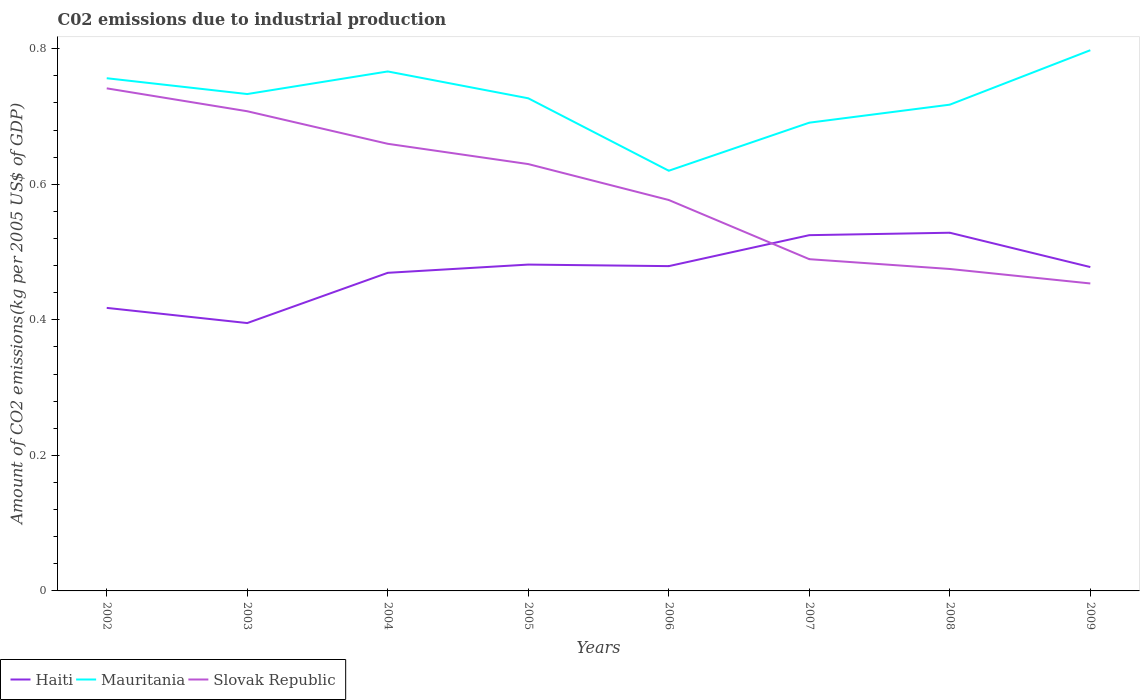Does the line corresponding to Haiti intersect with the line corresponding to Slovak Republic?
Keep it short and to the point. Yes. Across all years, what is the maximum amount of CO2 emitted due to industrial production in Slovak Republic?
Give a very brief answer. 0.45. In which year was the amount of CO2 emitted due to industrial production in Mauritania maximum?
Your answer should be compact. 2006. What is the total amount of CO2 emitted due to industrial production in Haiti in the graph?
Make the answer very short. -0.01. What is the difference between the highest and the second highest amount of CO2 emitted due to industrial production in Mauritania?
Your answer should be compact. 0.18. What is the difference between the highest and the lowest amount of CO2 emitted due to industrial production in Slovak Republic?
Your answer should be compact. 4. How many lines are there?
Give a very brief answer. 3. Does the graph contain grids?
Your answer should be very brief. No. Where does the legend appear in the graph?
Your answer should be compact. Bottom left. How many legend labels are there?
Provide a short and direct response. 3. What is the title of the graph?
Offer a terse response. C02 emissions due to industrial production. Does "Madagascar" appear as one of the legend labels in the graph?
Ensure brevity in your answer.  No. What is the label or title of the X-axis?
Provide a short and direct response. Years. What is the label or title of the Y-axis?
Make the answer very short. Amount of CO2 emissions(kg per 2005 US$ of GDP). What is the Amount of CO2 emissions(kg per 2005 US$ of GDP) in Haiti in 2002?
Provide a succinct answer. 0.42. What is the Amount of CO2 emissions(kg per 2005 US$ of GDP) of Mauritania in 2002?
Your answer should be very brief. 0.76. What is the Amount of CO2 emissions(kg per 2005 US$ of GDP) of Slovak Republic in 2002?
Provide a short and direct response. 0.74. What is the Amount of CO2 emissions(kg per 2005 US$ of GDP) in Haiti in 2003?
Ensure brevity in your answer.  0.4. What is the Amount of CO2 emissions(kg per 2005 US$ of GDP) of Mauritania in 2003?
Your response must be concise. 0.73. What is the Amount of CO2 emissions(kg per 2005 US$ of GDP) in Slovak Republic in 2003?
Offer a very short reply. 0.71. What is the Amount of CO2 emissions(kg per 2005 US$ of GDP) in Haiti in 2004?
Your response must be concise. 0.47. What is the Amount of CO2 emissions(kg per 2005 US$ of GDP) in Mauritania in 2004?
Provide a succinct answer. 0.77. What is the Amount of CO2 emissions(kg per 2005 US$ of GDP) in Slovak Republic in 2004?
Your answer should be very brief. 0.66. What is the Amount of CO2 emissions(kg per 2005 US$ of GDP) in Haiti in 2005?
Your response must be concise. 0.48. What is the Amount of CO2 emissions(kg per 2005 US$ of GDP) in Mauritania in 2005?
Give a very brief answer. 0.73. What is the Amount of CO2 emissions(kg per 2005 US$ of GDP) of Slovak Republic in 2005?
Provide a succinct answer. 0.63. What is the Amount of CO2 emissions(kg per 2005 US$ of GDP) in Haiti in 2006?
Provide a succinct answer. 0.48. What is the Amount of CO2 emissions(kg per 2005 US$ of GDP) of Mauritania in 2006?
Your response must be concise. 0.62. What is the Amount of CO2 emissions(kg per 2005 US$ of GDP) of Slovak Republic in 2006?
Offer a very short reply. 0.58. What is the Amount of CO2 emissions(kg per 2005 US$ of GDP) in Haiti in 2007?
Offer a very short reply. 0.52. What is the Amount of CO2 emissions(kg per 2005 US$ of GDP) in Mauritania in 2007?
Provide a succinct answer. 0.69. What is the Amount of CO2 emissions(kg per 2005 US$ of GDP) in Slovak Republic in 2007?
Your response must be concise. 0.49. What is the Amount of CO2 emissions(kg per 2005 US$ of GDP) of Haiti in 2008?
Give a very brief answer. 0.53. What is the Amount of CO2 emissions(kg per 2005 US$ of GDP) in Mauritania in 2008?
Give a very brief answer. 0.72. What is the Amount of CO2 emissions(kg per 2005 US$ of GDP) in Slovak Republic in 2008?
Ensure brevity in your answer.  0.48. What is the Amount of CO2 emissions(kg per 2005 US$ of GDP) in Haiti in 2009?
Provide a short and direct response. 0.48. What is the Amount of CO2 emissions(kg per 2005 US$ of GDP) of Mauritania in 2009?
Keep it short and to the point. 0.8. What is the Amount of CO2 emissions(kg per 2005 US$ of GDP) in Slovak Republic in 2009?
Your answer should be very brief. 0.45. Across all years, what is the maximum Amount of CO2 emissions(kg per 2005 US$ of GDP) of Haiti?
Your answer should be compact. 0.53. Across all years, what is the maximum Amount of CO2 emissions(kg per 2005 US$ of GDP) in Mauritania?
Your answer should be compact. 0.8. Across all years, what is the maximum Amount of CO2 emissions(kg per 2005 US$ of GDP) of Slovak Republic?
Ensure brevity in your answer.  0.74. Across all years, what is the minimum Amount of CO2 emissions(kg per 2005 US$ of GDP) in Haiti?
Offer a terse response. 0.4. Across all years, what is the minimum Amount of CO2 emissions(kg per 2005 US$ of GDP) of Mauritania?
Keep it short and to the point. 0.62. Across all years, what is the minimum Amount of CO2 emissions(kg per 2005 US$ of GDP) of Slovak Republic?
Make the answer very short. 0.45. What is the total Amount of CO2 emissions(kg per 2005 US$ of GDP) of Haiti in the graph?
Offer a terse response. 3.77. What is the total Amount of CO2 emissions(kg per 2005 US$ of GDP) in Mauritania in the graph?
Offer a terse response. 5.81. What is the total Amount of CO2 emissions(kg per 2005 US$ of GDP) of Slovak Republic in the graph?
Make the answer very short. 4.73. What is the difference between the Amount of CO2 emissions(kg per 2005 US$ of GDP) in Haiti in 2002 and that in 2003?
Provide a succinct answer. 0.02. What is the difference between the Amount of CO2 emissions(kg per 2005 US$ of GDP) of Mauritania in 2002 and that in 2003?
Your answer should be compact. 0.02. What is the difference between the Amount of CO2 emissions(kg per 2005 US$ of GDP) in Slovak Republic in 2002 and that in 2003?
Your answer should be compact. 0.03. What is the difference between the Amount of CO2 emissions(kg per 2005 US$ of GDP) of Haiti in 2002 and that in 2004?
Your response must be concise. -0.05. What is the difference between the Amount of CO2 emissions(kg per 2005 US$ of GDP) in Mauritania in 2002 and that in 2004?
Your response must be concise. -0.01. What is the difference between the Amount of CO2 emissions(kg per 2005 US$ of GDP) in Slovak Republic in 2002 and that in 2004?
Keep it short and to the point. 0.08. What is the difference between the Amount of CO2 emissions(kg per 2005 US$ of GDP) in Haiti in 2002 and that in 2005?
Your answer should be compact. -0.06. What is the difference between the Amount of CO2 emissions(kg per 2005 US$ of GDP) of Mauritania in 2002 and that in 2005?
Your response must be concise. 0.03. What is the difference between the Amount of CO2 emissions(kg per 2005 US$ of GDP) of Slovak Republic in 2002 and that in 2005?
Keep it short and to the point. 0.11. What is the difference between the Amount of CO2 emissions(kg per 2005 US$ of GDP) in Haiti in 2002 and that in 2006?
Offer a very short reply. -0.06. What is the difference between the Amount of CO2 emissions(kg per 2005 US$ of GDP) in Mauritania in 2002 and that in 2006?
Provide a short and direct response. 0.14. What is the difference between the Amount of CO2 emissions(kg per 2005 US$ of GDP) of Slovak Republic in 2002 and that in 2006?
Offer a terse response. 0.16. What is the difference between the Amount of CO2 emissions(kg per 2005 US$ of GDP) in Haiti in 2002 and that in 2007?
Your answer should be very brief. -0.11. What is the difference between the Amount of CO2 emissions(kg per 2005 US$ of GDP) in Mauritania in 2002 and that in 2007?
Your response must be concise. 0.07. What is the difference between the Amount of CO2 emissions(kg per 2005 US$ of GDP) of Slovak Republic in 2002 and that in 2007?
Provide a short and direct response. 0.25. What is the difference between the Amount of CO2 emissions(kg per 2005 US$ of GDP) in Haiti in 2002 and that in 2008?
Ensure brevity in your answer.  -0.11. What is the difference between the Amount of CO2 emissions(kg per 2005 US$ of GDP) of Mauritania in 2002 and that in 2008?
Offer a very short reply. 0.04. What is the difference between the Amount of CO2 emissions(kg per 2005 US$ of GDP) in Slovak Republic in 2002 and that in 2008?
Give a very brief answer. 0.27. What is the difference between the Amount of CO2 emissions(kg per 2005 US$ of GDP) in Haiti in 2002 and that in 2009?
Your answer should be compact. -0.06. What is the difference between the Amount of CO2 emissions(kg per 2005 US$ of GDP) in Mauritania in 2002 and that in 2009?
Make the answer very short. -0.04. What is the difference between the Amount of CO2 emissions(kg per 2005 US$ of GDP) in Slovak Republic in 2002 and that in 2009?
Your response must be concise. 0.29. What is the difference between the Amount of CO2 emissions(kg per 2005 US$ of GDP) of Haiti in 2003 and that in 2004?
Offer a terse response. -0.07. What is the difference between the Amount of CO2 emissions(kg per 2005 US$ of GDP) in Mauritania in 2003 and that in 2004?
Offer a very short reply. -0.03. What is the difference between the Amount of CO2 emissions(kg per 2005 US$ of GDP) in Slovak Republic in 2003 and that in 2004?
Your answer should be very brief. 0.05. What is the difference between the Amount of CO2 emissions(kg per 2005 US$ of GDP) in Haiti in 2003 and that in 2005?
Give a very brief answer. -0.09. What is the difference between the Amount of CO2 emissions(kg per 2005 US$ of GDP) of Mauritania in 2003 and that in 2005?
Ensure brevity in your answer.  0.01. What is the difference between the Amount of CO2 emissions(kg per 2005 US$ of GDP) in Slovak Republic in 2003 and that in 2005?
Provide a short and direct response. 0.08. What is the difference between the Amount of CO2 emissions(kg per 2005 US$ of GDP) in Haiti in 2003 and that in 2006?
Keep it short and to the point. -0.08. What is the difference between the Amount of CO2 emissions(kg per 2005 US$ of GDP) of Mauritania in 2003 and that in 2006?
Offer a very short reply. 0.11. What is the difference between the Amount of CO2 emissions(kg per 2005 US$ of GDP) in Slovak Republic in 2003 and that in 2006?
Your response must be concise. 0.13. What is the difference between the Amount of CO2 emissions(kg per 2005 US$ of GDP) of Haiti in 2003 and that in 2007?
Provide a short and direct response. -0.13. What is the difference between the Amount of CO2 emissions(kg per 2005 US$ of GDP) of Mauritania in 2003 and that in 2007?
Keep it short and to the point. 0.04. What is the difference between the Amount of CO2 emissions(kg per 2005 US$ of GDP) in Slovak Republic in 2003 and that in 2007?
Your answer should be very brief. 0.22. What is the difference between the Amount of CO2 emissions(kg per 2005 US$ of GDP) of Haiti in 2003 and that in 2008?
Your answer should be very brief. -0.13. What is the difference between the Amount of CO2 emissions(kg per 2005 US$ of GDP) of Mauritania in 2003 and that in 2008?
Give a very brief answer. 0.02. What is the difference between the Amount of CO2 emissions(kg per 2005 US$ of GDP) of Slovak Republic in 2003 and that in 2008?
Offer a very short reply. 0.23. What is the difference between the Amount of CO2 emissions(kg per 2005 US$ of GDP) in Haiti in 2003 and that in 2009?
Make the answer very short. -0.08. What is the difference between the Amount of CO2 emissions(kg per 2005 US$ of GDP) of Mauritania in 2003 and that in 2009?
Give a very brief answer. -0.06. What is the difference between the Amount of CO2 emissions(kg per 2005 US$ of GDP) of Slovak Republic in 2003 and that in 2009?
Provide a succinct answer. 0.25. What is the difference between the Amount of CO2 emissions(kg per 2005 US$ of GDP) in Haiti in 2004 and that in 2005?
Provide a short and direct response. -0.01. What is the difference between the Amount of CO2 emissions(kg per 2005 US$ of GDP) in Mauritania in 2004 and that in 2005?
Offer a terse response. 0.04. What is the difference between the Amount of CO2 emissions(kg per 2005 US$ of GDP) in Slovak Republic in 2004 and that in 2005?
Offer a terse response. 0.03. What is the difference between the Amount of CO2 emissions(kg per 2005 US$ of GDP) in Haiti in 2004 and that in 2006?
Provide a short and direct response. -0.01. What is the difference between the Amount of CO2 emissions(kg per 2005 US$ of GDP) in Mauritania in 2004 and that in 2006?
Ensure brevity in your answer.  0.15. What is the difference between the Amount of CO2 emissions(kg per 2005 US$ of GDP) in Slovak Republic in 2004 and that in 2006?
Offer a terse response. 0.08. What is the difference between the Amount of CO2 emissions(kg per 2005 US$ of GDP) of Haiti in 2004 and that in 2007?
Your response must be concise. -0.06. What is the difference between the Amount of CO2 emissions(kg per 2005 US$ of GDP) in Mauritania in 2004 and that in 2007?
Ensure brevity in your answer.  0.08. What is the difference between the Amount of CO2 emissions(kg per 2005 US$ of GDP) of Slovak Republic in 2004 and that in 2007?
Keep it short and to the point. 0.17. What is the difference between the Amount of CO2 emissions(kg per 2005 US$ of GDP) in Haiti in 2004 and that in 2008?
Ensure brevity in your answer.  -0.06. What is the difference between the Amount of CO2 emissions(kg per 2005 US$ of GDP) of Mauritania in 2004 and that in 2008?
Keep it short and to the point. 0.05. What is the difference between the Amount of CO2 emissions(kg per 2005 US$ of GDP) of Slovak Republic in 2004 and that in 2008?
Provide a succinct answer. 0.18. What is the difference between the Amount of CO2 emissions(kg per 2005 US$ of GDP) in Haiti in 2004 and that in 2009?
Keep it short and to the point. -0.01. What is the difference between the Amount of CO2 emissions(kg per 2005 US$ of GDP) in Mauritania in 2004 and that in 2009?
Provide a succinct answer. -0.03. What is the difference between the Amount of CO2 emissions(kg per 2005 US$ of GDP) in Slovak Republic in 2004 and that in 2009?
Provide a succinct answer. 0.21. What is the difference between the Amount of CO2 emissions(kg per 2005 US$ of GDP) of Haiti in 2005 and that in 2006?
Your response must be concise. 0. What is the difference between the Amount of CO2 emissions(kg per 2005 US$ of GDP) in Mauritania in 2005 and that in 2006?
Your answer should be very brief. 0.11. What is the difference between the Amount of CO2 emissions(kg per 2005 US$ of GDP) of Slovak Republic in 2005 and that in 2006?
Give a very brief answer. 0.05. What is the difference between the Amount of CO2 emissions(kg per 2005 US$ of GDP) of Haiti in 2005 and that in 2007?
Give a very brief answer. -0.04. What is the difference between the Amount of CO2 emissions(kg per 2005 US$ of GDP) of Mauritania in 2005 and that in 2007?
Give a very brief answer. 0.04. What is the difference between the Amount of CO2 emissions(kg per 2005 US$ of GDP) of Slovak Republic in 2005 and that in 2007?
Ensure brevity in your answer.  0.14. What is the difference between the Amount of CO2 emissions(kg per 2005 US$ of GDP) of Haiti in 2005 and that in 2008?
Your answer should be very brief. -0.05. What is the difference between the Amount of CO2 emissions(kg per 2005 US$ of GDP) in Mauritania in 2005 and that in 2008?
Provide a short and direct response. 0.01. What is the difference between the Amount of CO2 emissions(kg per 2005 US$ of GDP) of Slovak Republic in 2005 and that in 2008?
Make the answer very short. 0.15. What is the difference between the Amount of CO2 emissions(kg per 2005 US$ of GDP) of Haiti in 2005 and that in 2009?
Provide a short and direct response. 0. What is the difference between the Amount of CO2 emissions(kg per 2005 US$ of GDP) in Mauritania in 2005 and that in 2009?
Provide a succinct answer. -0.07. What is the difference between the Amount of CO2 emissions(kg per 2005 US$ of GDP) in Slovak Republic in 2005 and that in 2009?
Make the answer very short. 0.18. What is the difference between the Amount of CO2 emissions(kg per 2005 US$ of GDP) in Haiti in 2006 and that in 2007?
Keep it short and to the point. -0.05. What is the difference between the Amount of CO2 emissions(kg per 2005 US$ of GDP) of Mauritania in 2006 and that in 2007?
Offer a very short reply. -0.07. What is the difference between the Amount of CO2 emissions(kg per 2005 US$ of GDP) in Slovak Republic in 2006 and that in 2007?
Offer a very short reply. 0.09. What is the difference between the Amount of CO2 emissions(kg per 2005 US$ of GDP) of Haiti in 2006 and that in 2008?
Ensure brevity in your answer.  -0.05. What is the difference between the Amount of CO2 emissions(kg per 2005 US$ of GDP) in Mauritania in 2006 and that in 2008?
Offer a terse response. -0.1. What is the difference between the Amount of CO2 emissions(kg per 2005 US$ of GDP) in Slovak Republic in 2006 and that in 2008?
Your answer should be very brief. 0.1. What is the difference between the Amount of CO2 emissions(kg per 2005 US$ of GDP) of Haiti in 2006 and that in 2009?
Give a very brief answer. 0. What is the difference between the Amount of CO2 emissions(kg per 2005 US$ of GDP) of Mauritania in 2006 and that in 2009?
Provide a short and direct response. -0.18. What is the difference between the Amount of CO2 emissions(kg per 2005 US$ of GDP) of Slovak Republic in 2006 and that in 2009?
Provide a succinct answer. 0.12. What is the difference between the Amount of CO2 emissions(kg per 2005 US$ of GDP) of Haiti in 2007 and that in 2008?
Your answer should be very brief. -0. What is the difference between the Amount of CO2 emissions(kg per 2005 US$ of GDP) in Mauritania in 2007 and that in 2008?
Your answer should be very brief. -0.03. What is the difference between the Amount of CO2 emissions(kg per 2005 US$ of GDP) in Slovak Republic in 2007 and that in 2008?
Your response must be concise. 0.01. What is the difference between the Amount of CO2 emissions(kg per 2005 US$ of GDP) of Haiti in 2007 and that in 2009?
Give a very brief answer. 0.05. What is the difference between the Amount of CO2 emissions(kg per 2005 US$ of GDP) of Mauritania in 2007 and that in 2009?
Provide a succinct answer. -0.11. What is the difference between the Amount of CO2 emissions(kg per 2005 US$ of GDP) of Slovak Republic in 2007 and that in 2009?
Give a very brief answer. 0.04. What is the difference between the Amount of CO2 emissions(kg per 2005 US$ of GDP) in Haiti in 2008 and that in 2009?
Your answer should be compact. 0.05. What is the difference between the Amount of CO2 emissions(kg per 2005 US$ of GDP) of Mauritania in 2008 and that in 2009?
Your answer should be very brief. -0.08. What is the difference between the Amount of CO2 emissions(kg per 2005 US$ of GDP) in Slovak Republic in 2008 and that in 2009?
Your answer should be very brief. 0.02. What is the difference between the Amount of CO2 emissions(kg per 2005 US$ of GDP) of Haiti in 2002 and the Amount of CO2 emissions(kg per 2005 US$ of GDP) of Mauritania in 2003?
Provide a short and direct response. -0.32. What is the difference between the Amount of CO2 emissions(kg per 2005 US$ of GDP) in Haiti in 2002 and the Amount of CO2 emissions(kg per 2005 US$ of GDP) in Slovak Republic in 2003?
Your answer should be compact. -0.29. What is the difference between the Amount of CO2 emissions(kg per 2005 US$ of GDP) in Mauritania in 2002 and the Amount of CO2 emissions(kg per 2005 US$ of GDP) in Slovak Republic in 2003?
Your answer should be compact. 0.05. What is the difference between the Amount of CO2 emissions(kg per 2005 US$ of GDP) in Haiti in 2002 and the Amount of CO2 emissions(kg per 2005 US$ of GDP) in Mauritania in 2004?
Make the answer very short. -0.35. What is the difference between the Amount of CO2 emissions(kg per 2005 US$ of GDP) in Haiti in 2002 and the Amount of CO2 emissions(kg per 2005 US$ of GDP) in Slovak Republic in 2004?
Ensure brevity in your answer.  -0.24. What is the difference between the Amount of CO2 emissions(kg per 2005 US$ of GDP) of Mauritania in 2002 and the Amount of CO2 emissions(kg per 2005 US$ of GDP) of Slovak Republic in 2004?
Make the answer very short. 0.1. What is the difference between the Amount of CO2 emissions(kg per 2005 US$ of GDP) in Haiti in 2002 and the Amount of CO2 emissions(kg per 2005 US$ of GDP) in Mauritania in 2005?
Keep it short and to the point. -0.31. What is the difference between the Amount of CO2 emissions(kg per 2005 US$ of GDP) of Haiti in 2002 and the Amount of CO2 emissions(kg per 2005 US$ of GDP) of Slovak Republic in 2005?
Your response must be concise. -0.21. What is the difference between the Amount of CO2 emissions(kg per 2005 US$ of GDP) of Mauritania in 2002 and the Amount of CO2 emissions(kg per 2005 US$ of GDP) of Slovak Republic in 2005?
Your response must be concise. 0.13. What is the difference between the Amount of CO2 emissions(kg per 2005 US$ of GDP) of Haiti in 2002 and the Amount of CO2 emissions(kg per 2005 US$ of GDP) of Mauritania in 2006?
Make the answer very short. -0.2. What is the difference between the Amount of CO2 emissions(kg per 2005 US$ of GDP) of Haiti in 2002 and the Amount of CO2 emissions(kg per 2005 US$ of GDP) of Slovak Republic in 2006?
Ensure brevity in your answer.  -0.16. What is the difference between the Amount of CO2 emissions(kg per 2005 US$ of GDP) of Mauritania in 2002 and the Amount of CO2 emissions(kg per 2005 US$ of GDP) of Slovak Republic in 2006?
Your response must be concise. 0.18. What is the difference between the Amount of CO2 emissions(kg per 2005 US$ of GDP) of Haiti in 2002 and the Amount of CO2 emissions(kg per 2005 US$ of GDP) of Mauritania in 2007?
Ensure brevity in your answer.  -0.27. What is the difference between the Amount of CO2 emissions(kg per 2005 US$ of GDP) of Haiti in 2002 and the Amount of CO2 emissions(kg per 2005 US$ of GDP) of Slovak Republic in 2007?
Make the answer very short. -0.07. What is the difference between the Amount of CO2 emissions(kg per 2005 US$ of GDP) of Mauritania in 2002 and the Amount of CO2 emissions(kg per 2005 US$ of GDP) of Slovak Republic in 2007?
Provide a short and direct response. 0.27. What is the difference between the Amount of CO2 emissions(kg per 2005 US$ of GDP) in Haiti in 2002 and the Amount of CO2 emissions(kg per 2005 US$ of GDP) in Mauritania in 2008?
Your answer should be very brief. -0.3. What is the difference between the Amount of CO2 emissions(kg per 2005 US$ of GDP) of Haiti in 2002 and the Amount of CO2 emissions(kg per 2005 US$ of GDP) of Slovak Republic in 2008?
Your response must be concise. -0.06. What is the difference between the Amount of CO2 emissions(kg per 2005 US$ of GDP) of Mauritania in 2002 and the Amount of CO2 emissions(kg per 2005 US$ of GDP) of Slovak Republic in 2008?
Offer a very short reply. 0.28. What is the difference between the Amount of CO2 emissions(kg per 2005 US$ of GDP) of Haiti in 2002 and the Amount of CO2 emissions(kg per 2005 US$ of GDP) of Mauritania in 2009?
Give a very brief answer. -0.38. What is the difference between the Amount of CO2 emissions(kg per 2005 US$ of GDP) of Haiti in 2002 and the Amount of CO2 emissions(kg per 2005 US$ of GDP) of Slovak Republic in 2009?
Provide a succinct answer. -0.04. What is the difference between the Amount of CO2 emissions(kg per 2005 US$ of GDP) in Mauritania in 2002 and the Amount of CO2 emissions(kg per 2005 US$ of GDP) in Slovak Republic in 2009?
Offer a terse response. 0.3. What is the difference between the Amount of CO2 emissions(kg per 2005 US$ of GDP) of Haiti in 2003 and the Amount of CO2 emissions(kg per 2005 US$ of GDP) of Mauritania in 2004?
Your answer should be compact. -0.37. What is the difference between the Amount of CO2 emissions(kg per 2005 US$ of GDP) of Haiti in 2003 and the Amount of CO2 emissions(kg per 2005 US$ of GDP) of Slovak Republic in 2004?
Provide a short and direct response. -0.26. What is the difference between the Amount of CO2 emissions(kg per 2005 US$ of GDP) of Mauritania in 2003 and the Amount of CO2 emissions(kg per 2005 US$ of GDP) of Slovak Republic in 2004?
Offer a very short reply. 0.07. What is the difference between the Amount of CO2 emissions(kg per 2005 US$ of GDP) in Haiti in 2003 and the Amount of CO2 emissions(kg per 2005 US$ of GDP) in Mauritania in 2005?
Your answer should be compact. -0.33. What is the difference between the Amount of CO2 emissions(kg per 2005 US$ of GDP) of Haiti in 2003 and the Amount of CO2 emissions(kg per 2005 US$ of GDP) of Slovak Republic in 2005?
Your answer should be very brief. -0.23. What is the difference between the Amount of CO2 emissions(kg per 2005 US$ of GDP) in Mauritania in 2003 and the Amount of CO2 emissions(kg per 2005 US$ of GDP) in Slovak Republic in 2005?
Provide a succinct answer. 0.1. What is the difference between the Amount of CO2 emissions(kg per 2005 US$ of GDP) in Haiti in 2003 and the Amount of CO2 emissions(kg per 2005 US$ of GDP) in Mauritania in 2006?
Make the answer very short. -0.22. What is the difference between the Amount of CO2 emissions(kg per 2005 US$ of GDP) of Haiti in 2003 and the Amount of CO2 emissions(kg per 2005 US$ of GDP) of Slovak Republic in 2006?
Keep it short and to the point. -0.18. What is the difference between the Amount of CO2 emissions(kg per 2005 US$ of GDP) of Mauritania in 2003 and the Amount of CO2 emissions(kg per 2005 US$ of GDP) of Slovak Republic in 2006?
Provide a short and direct response. 0.16. What is the difference between the Amount of CO2 emissions(kg per 2005 US$ of GDP) of Haiti in 2003 and the Amount of CO2 emissions(kg per 2005 US$ of GDP) of Mauritania in 2007?
Ensure brevity in your answer.  -0.3. What is the difference between the Amount of CO2 emissions(kg per 2005 US$ of GDP) of Haiti in 2003 and the Amount of CO2 emissions(kg per 2005 US$ of GDP) of Slovak Republic in 2007?
Keep it short and to the point. -0.09. What is the difference between the Amount of CO2 emissions(kg per 2005 US$ of GDP) of Mauritania in 2003 and the Amount of CO2 emissions(kg per 2005 US$ of GDP) of Slovak Republic in 2007?
Provide a short and direct response. 0.24. What is the difference between the Amount of CO2 emissions(kg per 2005 US$ of GDP) of Haiti in 2003 and the Amount of CO2 emissions(kg per 2005 US$ of GDP) of Mauritania in 2008?
Give a very brief answer. -0.32. What is the difference between the Amount of CO2 emissions(kg per 2005 US$ of GDP) of Haiti in 2003 and the Amount of CO2 emissions(kg per 2005 US$ of GDP) of Slovak Republic in 2008?
Offer a very short reply. -0.08. What is the difference between the Amount of CO2 emissions(kg per 2005 US$ of GDP) of Mauritania in 2003 and the Amount of CO2 emissions(kg per 2005 US$ of GDP) of Slovak Republic in 2008?
Give a very brief answer. 0.26. What is the difference between the Amount of CO2 emissions(kg per 2005 US$ of GDP) of Haiti in 2003 and the Amount of CO2 emissions(kg per 2005 US$ of GDP) of Mauritania in 2009?
Your answer should be compact. -0.4. What is the difference between the Amount of CO2 emissions(kg per 2005 US$ of GDP) in Haiti in 2003 and the Amount of CO2 emissions(kg per 2005 US$ of GDP) in Slovak Republic in 2009?
Offer a very short reply. -0.06. What is the difference between the Amount of CO2 emissions(kg per 2005 US$ of GDP) of Mauritania in 2003 and the Amount of CO2 emissions(kg per 2005 US$ of GDP) of Slovak Republic in 2009?
Give a very brief answer. 0.28. What is the difference between the Amount of CO2 emissions(kg per 2005 US$ of GDP) of Haiti in 2004 and the Amount of CO2 emissions(kg per 2005 US$ of GDP) of Mauritania in 2005?
Provide a short and direct response. -0.26. What is the difference between the Amount of CO2 emissions(kg per 2005 US$ of GDP) of Haiti in 2004 and the Amount of CO2 emissions(kg per 2005 US$ of GDP) of Slovak Republic in 2005?
Keep it short and to the point. -0.16. What is the difference between the Amount of CO2 emissions(kg per 2005 US$ of GDP) in Mauritania in 2004 and the Amount of CO2 emissions(kg per 2005 US$ of GDP) in Slovak Republic in 2005?
Your response must be concise. 0.14. What is the difference between the Amount of CO2 emissions(kg per 2005 US$ of GDP) in Haiti in 2004 and the Amount of CO2 emissions(kg per 2005 US$ of GDP) in Mauritania in 2006?
Ensure brevity in your answer.  -0.15. What is the difference between the Amount of CO2 emissions(kg per 2005 US$ of GDP) in Haiti in 2004 and the Amount of CO2 emissions(kg per 2005 US$ of GDP) in Slovak Republic in 2006?
Your answer should be compact. -0.11. What is the difference between the Amount of CO2 emissions(kg per 2005 US$ of GDP) of Mauritania in 2004 and the Amount of CO2 emissions(kg per 2005 US$ of GDP) of Slovak Republic in 2006?
Provide a succinct answer. 0.19. What is the difference between the Amount of CO2 emissions(kg per 2005 US$ of GDP) of Haiti in 2004 and the Amount of CO2 emissions(kg per 2005 US$ of GDP) of Mauritania in 2007?
Keep it short and to the point. -0.22. What is the difference between the Amount of CO2 emissions(kg per 2005 US$ of GDP) of Haiti in 2004 and the Amount of CO2 emissions(kg per 2005 US$ of GDP) of Slovak Republic in 2007?
Offer a terse response. -0.02. What is the difference between the Amount of CO2 emissions(kg per 2005 US$ of GDP) of Mauritania in 2004 and the Amount of CO2 emissions(kg per 2005 US$ of GDP) of Slovak Republic in 2007?
Make the answer very short. 0.28. What is the difference between the Amount of CO2 emissions(kg per 2005 US$ of GDP) in Haiti in 2004 and the Amount of CO2 emissions(kg per 2005 US$ of GDP) in Mauritania in 2008?
Keep it short and to the point. -0.25. What is the difference between the Amount of CO2 emissions(kg per 2005 US$ of GDP) of Haiti in 2004 and the Amount of CO2 emissions(kg per 2005 US$ of GDP) of Slovak Republic in 2008?
Ensure brevity in your answer.  -0.01. What is the difference between the Amount of CO2 emissions(kg per 2005 US$ of GDP) of Mauritania in 2004 and the Amount of CO2 emissions(kg per 2005 US$ of GDP) of Slovak Republic in 2008?
Offer a very short reply. 0.29. What is the difference between the Amount of CO2 emissions(kg per 2005 US$ of GDP) in Haiti in 2004 and the Amount of CO2 emissions(kg per 2005 US$ of GDP) in Mauritania in 2009?
Your response must be concise. -0.33. What is the difference between the Amount of CO2 emissions(kg per 2005 US$ of GDP) in Haiti in 2004 and the Amount of CO2 emissions(kg per 2005 US$ of GDP) in Slovak Republic in 2009?
Keep it short and to the point. 0.02. What is the difference between the Amount of CO2 emissions(kg per 2005 US$ of GDP) in Mauritania in 2004 and the Amount of CO2 emissions(kg per 2005 US$ of GDP) in Slovak Republic in 2009?
Keep it short and to the point. 0.31. What is the difference between the Amount of CO2 emissions(kg per 2005 US$ of GDP) of Haiti in 2005 and the Amount of CO2 emissions(kg per 2005 US$ of GDP) of Mauritania in 2006?
Offer a very short reply. -0.14. What is the difference between the Amount of CO2 emissions(kg per 2005 US$ of GDP) in Haiti in 2005 and the Amount of CO2 emissions(kg per 2005 US$ of GDP) in Slovak Republic in 2006?
Your response must be concise. -0.1. What is the difference between the Amount of CO2 emissions(kg per 2005 US$ of GDP) of Mauritania in 2005 and the Amount of CO2 emissions(kg per 2005 US$ of GDP) of Slovak Republic in 2006?
Your response must be concise. 0.15. What is the difference between the Amount of CO2 emissions(kg per 2005 US$ of GDP) of Haiti in 2005 and the Amount of CO2 emissions(kg per 2005 US$ of GDP) of Mauritania in 2007?
Make the answer very short. -0.21. What is the difference between the Amount of CO2 emissions(kg per 2005 US$ of GDP) in Haiti in 2005 and the Amount of CO2 emissions(kg per 2005 US$ of GDP) in Slovak Republic in 2007?
Provide a succinct answer. -0.01. What is the difference between the Amount of CO2 emissions(kg per 2005 US$ of GDP) in Mauritania in 2005 and the Amount of CO2 emissions(kg per 2005 US$ of GDP) in Slovak Republic in 2007?
Your answer should be compact. 0.24. What is the difference between the Amount of CO2 emissions(kg per 2005 US$ of GDP) in Haiti in 2005 and the Amount of CO2 emissions(kg per 2005 US$ of GDP) in Mauritania in 2008?
Your answer should be very brief. -0.24. What is the difference between the Amount of CO2 emissions(kg per 2005 US$ of GDP) of Haiti in 2005 and the Amount of CO2 emissions(kg per 2005 US$ of GDP) of Slovak Republic in 2008?
Offer a terse response. 0.01. What is the difference between the Amount of CO2 emissions(kg per 2005 US$ of GDP) of Mauritania in 2005 and the Amount of CO2 emissions(kg per 2005 US$ of GDP) of Slovak Republic in 2008?
Offer a terse response. 0.25. What is the difference between the Amount of CO2 emissions(kg per 2005 US$ of GDP) in Haiti in 2005 and the Amount of CO2 emissions(kg per 2005 US$ of GDP) in Mauritania in 2009?
Your answer should be very brief. -0.32. What is the difference between the Amount of CO2 emissions(kg per 2005 US$ of GDP) in Haiti in 2005 and the Amount of CO2 emissions(kg per 2005 US$ of GDP) in Slovak Republic in 2009?
Make the answer very short. 0.03. What is the difference between the Amount of CO2 emissions(kg per 2005 US$ of GDP) in Mauritania in 2005 and the Amount of CO2 emissions(kg per 2005 US$ of GDP) in Slovak Republic in 2009?
Your response must be concise. 0.27. What is the difference between the Amount of CO2 emissions(kg per 2005 US$ of GDP) in Haiti in 2006 and the Amount of CO2 emissions(kg per 2005 US$ of GDP) in Mauritania in 2007?
Provide a short and direct response. -0.21. What is the difference between the Amount of CO2 emissions(kg per 2005 US$ of GDP) in Haiti in 2006 and the Amount of CO2 emissions(kg per 2005 US$ of GDP) in Slovak Republic in 2007?
Provide a succinct answer. -0.01. What is the difference between the Amount of CO2 emissions(kg per 2005 US$ of GDP) in Mauritania in 2006 and the Amount of CO2 emissions(kg per 2005 US$ of GDP) in Slovak Republic in 2007?
Offer a terse response. 0.13. What is the difference between the Amount of CO2 emissions(kg per 2005 US$ of GDP) in Haiti in 2006 and the Amount of CO2 emissions(kg per 2005 US$ of GDP) in Mauritania in 2008?
Keep it short and to the point. -0.24. What is the difference between the Amount of CO2 emissions(kg per 2005 US$ of GDP) in Haiti in 2006 and the Amount of CO2 emissions(kg per 2005 US$ of GDP) in Slovak Republic in 2008?
Offer a very short reply. 0. What is the difference between the Amount of CO2 emissions(kg per 2005 US$ of GDP) in Mauritania in 2006 and the Amount of CO2 emissions(kg per 2005 US$ of GDP) in Slovak Republic in 2008?
Ensure brevity in your answer.  0.14. What is the difference between the Amount of CO2 emissions(kg per 2005 US$ of GDP) of Haiti in 2006 and the Amount of CO2 emissions(kg per 2005 US$ of GDP) of Mauritania in 2009?
Offer a very short reply. -0.32. What is the difference between the Amount of CO2 emissions(kg per 2005 US$ of GDP) of Haiti in 2006 and the Amount of CO2 emissions(kg per 2005 US$ of GDP) of Slovak Republic in 2009?
Keep it short and to the point. 0.03. What is the difference between the Amount of CO2 emissions(kg per 2005 US$ of GDP) of Mauritania in 2006 and the Amount of CO2 emissions(kg per 2005 US$ of GDP) of Slovak Republic in 2009?
Your answer should be very brief. 0.17. What is the difference between the Amount of CO2 emissions(kg per 2005 US$ of GDP) in Haiti in 2007 and the Amount of CO2 emissions(kg per 2005 US$ of GDP) in Mauritania in 2008?
Your answer should be compact. -0.19. What is the difference between the Amount of CO2 emissions(kg per 2005 US$ of GDP) of Haiti in 2007 and the Amount of CO2 emissions(kg per 2005 US$ of GDP) of Slovak Republic in 2008?
Your answer should be very brief. 0.05. What is the difference between the Amount of CO2 emissions(kg per 2005 US$ of GDP) in Mauritania in 2007 and the Amount of CO2 emissions(kg per 2005 US$ of GDP) in Slovak Republic in 2008?
Offer a terse response. 0.22. What is the difference between the Amount of CO2 emissions(kg per 2005 US$ of GDP) in Haiti in 2007 and the Amount of CO2 emissions(kg per 2005 US$ of GDP) in Mauritania in 2009?
Ensure brevity in your answer.  -0.27. What is the difference between the Amount of CO2 emissions(kg per 2005 US$ of GDP) in Haiti in 2007 and the Amount of CO2 emissions(kg per 2005 US$ of GDP) in Slovak Republic in 2009?
Ensure brevity in your answer.  0.07. What is the difference between the Amount of CO2 emissions(kg per 2005 US$ of GDP) of Mauritania in 2007 and the Amount of CO2 emissions(kg per 2005 US$ of GDP) of Slovak Republic in 2009?
Provide a short and direct response. 0.24. What is the difference between the Amount of CO2 emissions(kg per 2005 US$ of GDP) of Haiti in 2008 and the Amount of CO2 emissions(kg per 2005 US$ of GDP) of Mauritania in 2009?
Offer a very short reply. -0.27. What is the difference between the Amount of CO2 emissions(kg per 2005 US$ of GDP) in Haiti in 2008 and the Amount of CO2 emissions(kg per 2005 US$ of GDP) in Slovak Republic in 2009?
Ensure brevity in your answer.  0.07. What is the difference between the Amount of CO2 emissions(kg per 2005 US$ of GDP) in Mauritania in 2008 and the Amount of CO2 emissions(kg per 2005 US$ of GDP) in Slovak Republic in 2009?
Make the answer very short. 0.26. What is the average Amount of CO2 emissions(kg per 2005 US$ of GDP) in Haiti per year?
Provide a short and direct response. 0.47. What is the average Amount of CO2 emissions(kg per 2005 US$ of GDP) of Mauritania per year?
Offer a very short reply. 0.73. What is the average Amount of CO2 emissions(kg per 2005 US$ of GDP) of Slovak Republic per year?
Ensure brevity in your answer.  0.59. In the year 2002, what is the difference between the Amount of CO2 emissions(kg per 2005 US$ of GDP) of Haiti and Amount of CO2 emissions(kg per 2005 US$ of GDP) of Mauritania?
Ensure brevity in your answer.  -0.34. In the year 2002, what is the difference between the Amount of CO2 emissions(kg per 2005 US$ of GDP) in Haiti and Amount of CO2 emissions(kg per 2005 US$ of GDP) in Slovak Republic?
Offer a very short reply. -0.32. In the year 2002, what is the difference between the Amount of CO2 emissions(kg per 2005 US$ of GDP) in Mauritania and Amount of CO2 emissions(kg per 2005 US$ of GDP) in Slovak Republic?
Give a very brief answer. 0.01. In the year 2003, what is the difference between the Amount of CO2 emissions(kg per 2005 US$ of GDP) in Haiti and Amount of CO2 emissions(kg per 2005 US$ of GDP) in Mauritania?
Provide a short and direct response. -0.34. In the year 2003, what is the difference between the Amount of CO2 emissions(kg per 2005 US$ of GDP) of Haiti and Amount of CO2 emissions(kg per 2005 US$ of GDP) of Slovak Republic?
Your answer should be compact. -0.31. In the year 2003, what is the difference between the Amount of CO2 emissions(kg per 2005 US$ of GDP) of Mauritania and Amount of CO2 emissions(kg per 2005 US$ of GDP) of Slovak Republic?
Your response must be concise. 0.03. In the year 2004, what is the difference between the Amount of CO2 emissions(kg per 2005 US$ of GDP) in Haiti and Amount of CO2 emissions(kg per 2005 US$ of GDP) in Mauritania?
Your answer should be compact. -0.3. In the year 2004, what is the difference between the Amount of CO2 emissions(kg per 2005 US$ of GDP) in Haiti and Amount of CO2 emissions(kg per 2005 US$ of GDP) in Slovak Republic?
Your response must be concise. -0.19. In the year 2004, what is the difference between the Amount of CO2 emissions(kg per 2005 US$ of GDP) of Mauritania and Amount of CO2 emissions(kg per 2005 US$ of GDP) of Slovak Republic?
Offer a terse response. 0.11. In the year 2005, what is the difference between the Amount of CO2 emissions(kg per 2005 US$ of GDP) of Haiti and Amount of CO2 emissions(kg per 2005 US$ of GDP) of Mauritania?
Keep it short and to the point. -0.25. In the year 2005, what is the difference between the Amount of CO2 emissions(kg per 2005 US$ of GDP) in Haiti and Amount of CO2 emissions(kg per 2005 US$ of GDP) in Slovak Republic?
Keep it short and to the point. -0.15. In the year 2005, what is the difference between the Amount of CO2 emissions(kg per 2005 US$ of GDP) of Mauritania and Amount of CO2 emissions(kg per 2005 US$ of GDP) of Slovak Republic?
Offer a very short reply. 0.1. In the year 2006, what is the difference between the Amount of CO2 emissions(kg per 2005 US$ of GDP) of Haiti and Amount of CO2 emissions(kg per 2005 US$ of GDP) of Mauritania?
Offer a very short reply. -0.14. In the year 2006, what is the difference between the Amount of CO2 emissions(kg per 2005 US$ of GDP) of Haiti and Amount of CO2 emissions(kg per 2005 US$ of GDP) of Slovak Republic?
Provide a short and direct response. -0.1. In the year 2006, what is the difference between the Amount of CO2 emissions(kg per 2005 US$ of GDP) of Mauritania and Amount of CO2 emissions(kg per 2005 US$ of GDP) of Slovak Republic?
Provide a succinct answer. 0.04. In the year 2007, what is the difference between the Amount of CO2 emissions(kg per 2005 US$ of GDP) of Haiti and Amount of CO2 emissions(kg per 2005 US$ of GDP) of Mauritania?
Your answer should be very brief. -0.17. In the year 2007, what is the difference between the Amount of CO2 emissions(kg per 2005 US$ of GDP) in Haiti and Amount of CO2 emissions(kg per 2005 US$ of GDP) in Slovak Republic?
Keep it short and to the point. 0.04. In the year 2007, what is the difference between the Amount of CO2 emissions(kg per 2005 US$ of GDP) of Mauritania and Amount of CO2 emissions(kg per 2005 US$ of GDP) of Slovak Republic?
Offer a very short reply. 0.2. In the year 2008, what is the difference between the Amount of CO2 emissions(kg per 2005 US$ of GDP) of Haiti and Amount of CO2 emissions(kg per 2005 US$ of GDP) of Mauritania?
Give a very brief answer. -0.19. In the year 2008, what is the difference between the Amount of CO2 emissions(kg per 2005 US$ of GDP) of Haiti and Amount of CO2 emissions(kg per 2005 US$ of GDP) of Slovak Republic?
Give a very brief answer. 0.05. In the year 2008, what is the difference between the Amount of CO2 emissions(kg per 2005 US$ of GDP) of Mauritania and Amount of CO2 emissions(kg per 2005 US$ of GDP) of Slovak Republic?
Your answer should be very brief. 0.24. In the year 2009, what is the difference between the Amount of CO2 emissions(kg per 2005 US$ of GDP) of Haiti and Amount of CO2 emissions(kg per 2005 US$ of GDP) of Mauritania?
Offer a very short reply. -0.32. In the year 2009, what is the difference between the Amount of CO2 emissions(kg per 2005 US$ of GDP) in Haiti and Amount of CO2 emissions(kg per 2005 US$ of GDP) in Slovak Republic?
Keep it short and to the point. 0.02. In the year 2009, what is the difference between the Amount of CO2 emissions(kg per 2005 US$ of GDP) in Mauritania and Amount of CO2 emissions(kg per 2005 US$ of GDP) in Slovak Republic?
Offer a terse response. 0.34. What is the ratio of the Amount of CO2 emissions(kg per 2005 US$ of GDP) in Haiti in 2002 to that in 2003?
Your answer should be compact. 1.06. What is the ratio of the Amount of CO2 emissions(kg per 2005 US$ of GDP) in Mauritania in 2002 to that in 2003?
Your response must be concise. 1.03. What is the ratio of the Amount of CO2 emissions(kg per 2005 US$ of GDP) of Slovak Republic in 2002 to that in 2003?
Your answer should be very brief. 1.05. What is the ratio of the Amount of CO2 emissions(kg per 2005 US$ of GDP) of Haiti in 2002 to that in 2004?
Provide a succinct answer. 0.89. What is the ratio of the Amount of CO2 emissions(kg per 2005 US$ of GDP) of Slovak Republic in 2002 to that in 2004?
Provide a short and direct response. 1.12. What is the ratio of the Amount of CO2 emissions(kg per 2005 US$ of GDP) of Haiti in 2002 to that in 2005?
Keep it short and to the point. 0.87. What is the ratio of the Amount of CO2 emissions(kg per 2005 US$ of GDP) in Mauritania in 2002 to that in 2005?
Make the answer very short. 1.04. What is the ratio of the Amount of CO2 emissions(kg per 2005 US$ of GDP) in Slovak Republic in 2002 to that in 2005?
Your answer should be compact. 1.18. What is the ratio of the Amount of CO2 emissions(kg per 2005 US$ of GDP) of Haiti in 2002 to that in 2006?
Your response must be concise. 0.87. What is the ratio of the Amount of CO2 emissions(kg per 2005 US$ of GDP) in Mauritania in 2002 to that in 2006?
Your answer should be very brief. 1.22. What is the ratio of the Amount of CO2 emissions(kg per 2005 US$ of GDP) of Slovak Republic in 2002 to that in 2006?
Keep it short and to the point. 1.29. What is the ratio of the Amount of CO2 emissions(kg per 2005 US$ of GDP) of Haiti in 2002 to that in 2007?
Keep it short and to the point. 0.8. What is the ratio of the Amount of CO2 emissions(kg per 2005 US$ of GDP) of Mauritania in 2002 to that in 2007?
Offer a terse response. 1.09. What is the ratio of the Amount of CO2 emissions(kg per 2005 US$ of GDP) of Slovak Republic in 2002 to that in 2007?
Provide a short and direct response. 1.51. What is the ratio of the Amount of CO2 emissions(kg per 2005 US$ of GDP) in Haiti in 2002 to that in 2008?
Provide a succinct answer. 0.79. What is the ratio of the Amount of CO2 emissions(kg per 2005 US$ of GDP) of Mauritania in 2002 to that in 2008?
Offer a very short reply. 1.05. What is the ratio of the Amount of CO2 emissions(kg per 2005 US$ of GDP) in Slovak Republic in 2002 to that in 2008?
Provide a short and direct response. 1.56. What is the ratio of the Amount of CO2 emissions(kg per 2005 US$ of GDP) in Haiti in 2002 to that in 2009?
Your response must be concise. 0.87. What is the ratio of the Amount of CO2 emissions(kg per 2005 US$ of GDP) in Mauritania in 2002 to that in 2009?
Your response must be concise. 0.95. What is the ratio of the Amount of CO2 emissions(kg per 2005 US$ of GDP) in Slovak Republic in 2002 to that in 2009?
Give a very brief answer. 1.63. What is the ratio of the Amount of CO2 emissions(kg per 2005 US$ of GDP) of Haiti in 2003 to that in 2004?
Provide a short and direct response. 0.84. What is the ratio of the Amount of CO2 emissions(kg per 2005 US$ of GDP) of Mauritania in 2003 to that in 2004?
Your answer should be compact. 0.96. What is the ratio of the Amount of CO2 emissions(kg per 2005 US$ of GDP) in Slovak Republic in 2003 to that in 2004?
Keep it short and to the point. 1.07. What is the ratio of the Amount of CO2 emissions(kg per 2005 US$ of GDP) of Haiti in 2003 to that in 2005?
Offer a very short reply. 0.82. What is the ratio of the Amount of CO2 emissions(kg per 2005 US$ of GDP) of Mauritania in 2003 to that in 2005?
Give a very brief answer. 1.01. What is the ratio of the Amount of CO2 emissions(kg per 2005 US$ of GDP) of Slovak Republic in 2003 to that in 2005?
Provide a succinct answer. 1.12. What is the ratio of the Amount of CO2 emissions(kg per 2005 US$ of GDP) in Haiti in 2003 to that in 2006?
Keep it short and to the point. 0.82. What is the ratio of the Amount of CO2 emissions(kg per 2005 US$ of GDP) in Mauritania in 2003 to that in 2006?
Provide a short and direct response. 1.18. What is the ratio of the Amount of CO2 emissions(kg per 2005 US$ of GDP) in Slovak Republic in 2003 to that in 2006?
Make the answer very short. 1.23. What is the ratio of the Amount of CO2 emissions(kg per 2005 US$ of GDP) of Haiti in 2003 to that in 2007?
Ensure brevity in your answer.  0.75. What is the ratio of the Amount of CO2 emissions(kg per 2005 US$ of GDP) in Mauritania in 2003 to that in 2007?
Offer a very short reply. 1.06. What is the ratio of the Amount of CO2 emissions(kg per 2005 US$ of GDP) in Slovak Republic in 2003 to that in 2007?
Your answer should be very brief. 1.45. What is the ratio of the Amount of CO2 emissions(kg per 2005 US$ of GDP) in Haiti in 2003 to that in 2008?
Provide a succinct answer. 0.75. What is the ratio of the Amount of CO2 emissions(kg per 2005 US$ of GDP) of Mauritania in 2003 to that in 2008?
Your answer should be compact. 1.02. What is the ratio of the Amount of CO2 emissions(kg per 2005 US$ of GDP) of Slovak Republic in 2003 to that in 2008?
Offer a very short reply. 1.49. What is the ratio of the Amount of CO2 emissions(kg per 2005 US$ of GDP) of Haiti in 2003 to that in 2009?
Offer a terse response. 0.83. What is the ratio of the Amount of CO2 emissions(kg per 2005 US$ of GDP) in Mauritania in 2003 to that in 2009?
Offer a very short reply. 0.92. What is the ratio of the Amount of CO2 emissions(kg per 2005 US$ of GDP) in Slovak Republic in 2003 to that in 2009?
Your answer should be compact. 1.56. What is the ratio of the Amount of CO2 emissions(kg per 2005 US$ of GDP) in Haiti in 2004 to that in 2005?
Offer a very short reply. 0.97. What is the ratio of the Amount of CO2 emissions(kg per 2005 US$ of GDP) of Mauritania in 2004 to that in 2005?
Your response must be concise. 1.05. What is the ratio of the Amount of CO2 emissions(kg per 2005 US$ of GDP) of Slovak Republic in 2004 to that in 2005?
Your answer should be very brief. 1.05. What is the ratio of the Amount of CO2 emissions(kg per 2005 US$ of GDP) of Haiti in 2004 to that in 2006?
Your response must be concise. 0.98. What is the ratio of the Amount of CO2 emissions(kg per 2005 US$ of GDP) in Mauritania in 2004 to that in 2006?
Ensure brevity in your answer.  1.24. What is the ratio of the Amount of CO2 emissions(kg per 2005 US$ of GDP) of Slovak Republic in 2004 to that in 2006?
Offer a terse response. 1.14. What is the ratio of the Amount of CO2 emissions(kg per 2005 US$ of GDP) of Haiti in 2004 to that in 2007?
Make the answer very short. 0.89. What is the ratio of the Amount of CO2 emissions(kg per 2005 US$ of GDP) in Mauritania in 2004 to that in 2007?
Provide a succinct answer. 1.11. What is the ratio of the Amount of CO2 emissions(kg per 2005 US$ of GDP) in Slovak Republic in 2004 to that in 2007?
Ensure brevity in your answer.  1.35. What is the ratio of the Amount of CO2 emissions(kg per 2005 US$ of GDP) of Haiti in 2004 to that in 2008?
Your answer should be very brief. 0.89. What is the ratio of the Amount of CO2 emissions(kg per 2005 US$ of GDP) of Mauritania in 2004 to that in 2008?
Offer a very short reply. 1.07. What is the ratio of the Amount of CO2 emissions(kg per 2005 US$ of GDP) of Slovak Republic in 2004 to that in 2008?
Your response must be concise. 1.39. What is the ratio of the Amount of CO2 emissions(kg per 2005 US$ of GDP) of Haiti in 2004 to that in 2009?
Give a very brief answer. 0.98. What is the ratio of the Amount of CO2 emissions(kg per 2005 US$ of GDP) in Mauritania in 2004 to that in 2009?
Keep it short and to the point. 0.96. What is the ratio of the Amount of CO2 emissions(kg per 2005 US$ of GDP) in Slovak Republic in 2004 to that in 2009?
Your response must be concise. 1.45. What is the ratio of the Amount of CO2 emissions(kg per 2005 US$ of GDP) in Haiti in 2005 to that in 2006?
Provide a succinct answer. 1. What is the ratio of the Amount of CO2 emissions(kg per 2005 US$ of GDP) in Mauritania in 2005 to that in 2006?
Ensure brevity in your answer.  1.17. What is the ratio of the Amount of CO2 emissions(kg per 2005 US$ of GDP) of Slovak Republic in 2005 to that in 2006?
Make the answer very short. 1.09. What is the ratio of the Amount of CO2 emissions(kg per 2005 US$ of GDP) of Haiti in 2005 to that in 2007?
Your response must be concise. 0.92. What is the ratio of the Amount of CO2 emissions(kg per 2005 US$ of GDP) of Mauritania in 2005 to that in 2007?
Give a very brief answer. 1.05. What is the ratio of the Amount of CO2 emissions(kg per 2005 US$ of GDP) in Slovak Republic in 2005 to that in 2007?
Your answer should be compact. 1.29. What is the ratio of the Amount of CO2 emissions(kg per 2005 US$ of GDP) in Haiti in 2005 to that in 2008?
Give a very brief answer. 0.91. What is the ratio of the Amount of CO2 emissions(kg per 2005 US$ of GDP) in Mauritania in 2005 to that in 2008?
Your answer should be compact. 1.01. What is the ratio of the Amount of CO2 emissions(kg per 2005 US$ of GDP) in Slovak Republic in 2005 to that in 2008?
Provide a succinct answer. 1.33. What is the ratio of the Amount of CO2 emissions(kg per 2005 US$ of GDP) of Haiti in 2005 to that in 2009?
Make the answer very short. 1.01. What is the ratio of the Amount of CO2 emissions(kg per 2005 US$ of GDP) in Mauritania in 2005 to that in 2009?
Provide a succinct answer. 0.91. What is the ratio of the Amount of CO2 emissions(kg per 2005 US$ of GDP) in Slovak Republic in 2005 to that in 2009?
Provide a succinct answer. 1.39. What is the ratio of the Amount of CO2 emissions(kg per 2005 US$ of GDP) of Haiti in 2006 to that in 2007?
Keep it short and to the point. 0.91. What is the ratio of the Amount of CO2 emissions(kg per 2005 US$ of GDP) of Mauritania in 2006 to that in 2007?
Give a very brief answer. 0.9. What is the ratio of the Amount of CO2 emissions(kg per 2005 US$ of GDP) in Slovak Republic in 2006 to that in 2007?
Make the answer very short. 1.18. What is the ratio of the Amount of CO2 emissions(kg per 2005 US$ of GDP) of Haiti in 2006 to that in 2008?
Your response must be concise. 0.91. What is the ratio of the Amount of CO2 emissions(kg per 2005 US$ of GDP) of Mauritania in 2006 to that in 2008?
Provide a succinct answer. 0.86. What is the ratio of the Amount of CO2 emissions(kg per 2005 US$ of GDP) in Slovak Republic in 2006 to that in 2008?
Your answer should be compact. 1.21. What is the ratio of the Amount of CO2 emissions(kg per 2005 US$ of GDP) in Mauritania in 2006 to that in 2009?
Offer a very short reply. 0.78. What is the ratio of the Amount of CO2 emissions(kg per 2005 US$ of GDP) of Slovak Republic in 2006 to that in 2009?
Give a very brief answer. 1.27. What is the ratio of the Amount of CO2 emissions(kg per 2005 US$ of GDP) of Mauritania in 2007 to that in 2008?
Offer a terse response. 0.96. What is the ratio of the Amount of CO2 emissions(kg per 2005 US$ of GDP) of Slovak Republic in 2007 to that in 2008?
Provide a succinct answer. 1.03. What is the ratio of the Amount of CO2 emissions(kg per 2005 US$ of GDP) in Haiti in 2007 to that in 2009?
Offer a terse response. 1.1. What is the ratio of the Amount of CO2 emissions(kg per 2005 US$ of GDP) in Mauritania in 2007 to that in 2009?
Your answer should be compact. 0.87. What is the ratio of the Amount of CO2 emissions(kg per 2005 US$ of GDP) of Slovak Republic in 2007 to that in 2009?
Give a very brief answer. 1.08. What is the ratio of the Amount of CO2 emissions(kg per 2005 US$ of GDP) in Haiti in 2008 to that in 2009?
Your answer should be compact. 1.11. What is the ratio of the Amount of CO2 emissions(kg per 2005 US$ of GDP) of Mauritania in 2008 to that in 2009?
Your answer should be compact. 0.9. What is the ratio of the Amount of CO2 emissions(kg per 2005 US$ of GDP) of Slovak Republic in 2008 to that in 2009?
Ensure brevity in your answer.  1.05. What is the difference between the highest and the second highest Amount of CO2 emissions(kg per 2005 US$ of GDP) of Haiti?
Offer a terse response. 0. What is the difference between the highest and the second highest Amount of CO2 emissions(kg per 2005 US$ of GDP) of Mauritania?
Offer a terse response. 0.03. What is the difference between the highest and the second highest Amount of CO2 emissions(kg per 2005 US$ of GDP) of Slovak Republic?
Keep it short and to the point. 0.03. What is the difference between the highest and the lowest Amount of CO2 emissions(kg per 2005 US$ of GDP) of Haiti?
Provide a succinct answer. 0.13. What is the difference between the highest and the lowest Amount of CO2 emissions(kg per 2005 US$ of GDP) in Mauritania?
Provide a short and direct response. 0.18. What is the difference between the highest and the lowest Amount of CO2 emissions(kg per 2005 US$ of GDP) in Slovak Republic?
Keep it short and to the point. 0.29. 